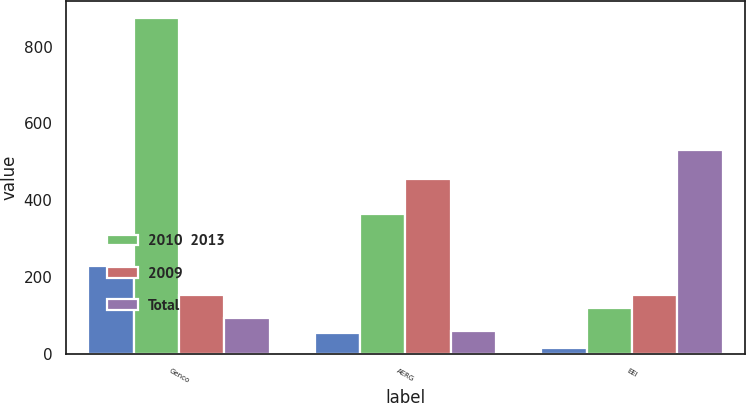<chart> <loc_0><loc_0><loc_500><loc_500><stacked_bar_chart><ecel><fcel>Genco<fcel>AERG<fcel>EEI<nl><fcel>nan<fcel>230<fcel>55<fcel>15<nl><fcel>2010  2013<fcel>875<fcel>365<fcel>120<nl><fcel>2009<fcel>155<fcel>455<fcel>155<nl><fcel>Total<fcel>95<fcel>60<fcel>530<nl></chart> 